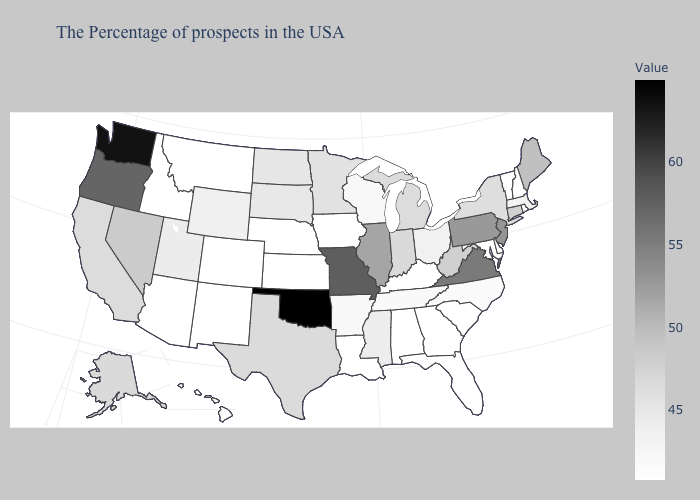Which states have the lowest value in the Northeast?
Quick response, please. Rhode Island, New Hampshire, Vermont. Is the legend a continuous bar?
Concise answer only. Yes. Is the legend a continuous bar?
Quick response, please. Yes. Among the states that border Missouri , which have the highest value?
Short answer required. Oklahoma. Does New Jersey have a higher value than Oregon?
Short answer required. No. 